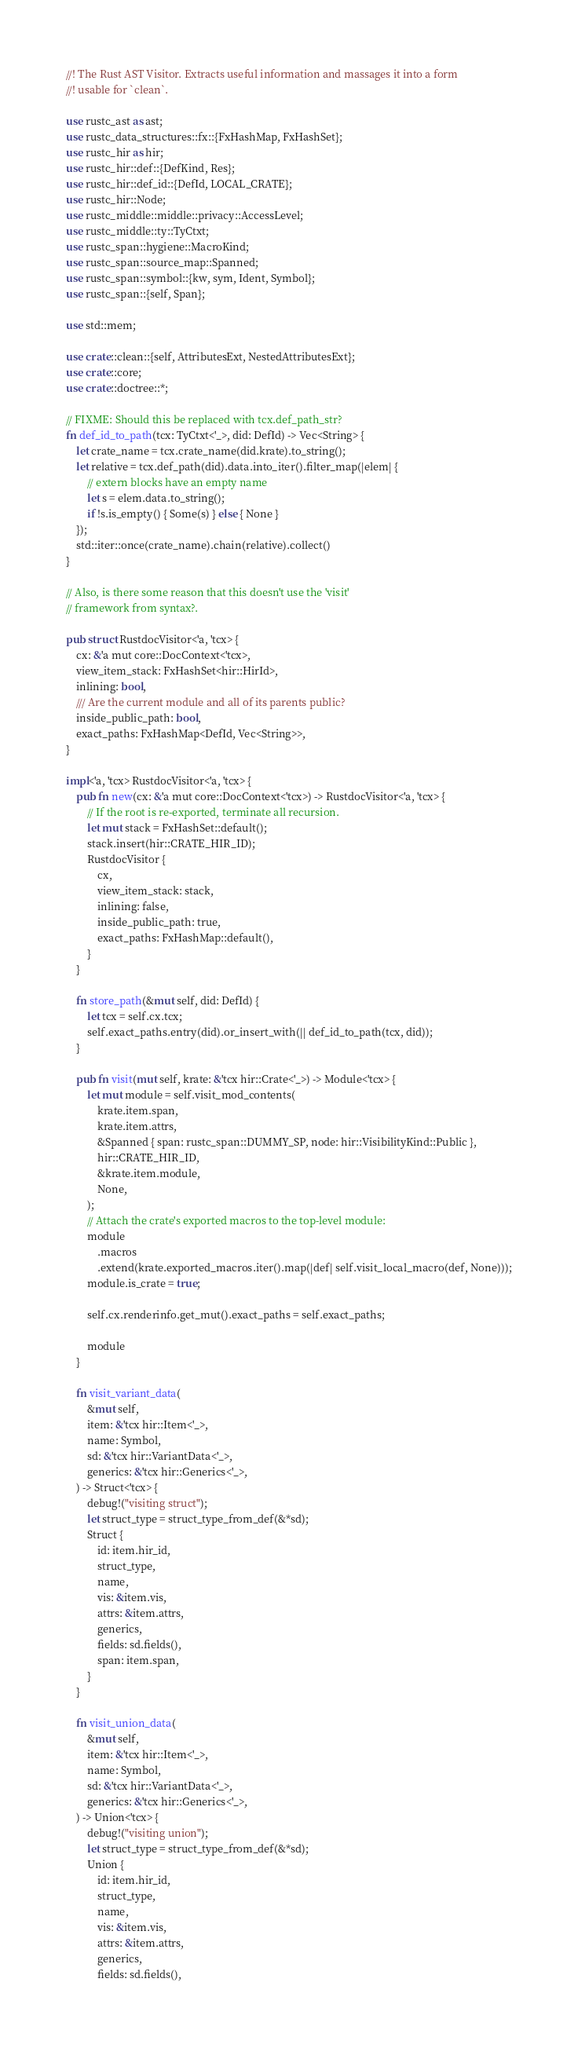Convert code to text. <code><loc_0><loc_0><loc_500><loc_500><_Rust_>//! The Rust AST Visitor. Extracts useful information and massages it into a form
//! usable for `clean`.

use rustc_ast as ast;
use rustc_data_structures::fx::{FxHashMap, FxHashSet};
use rustc_hir as hir;
use rustc_hir::def::{DefKind, Res};
use rustc_hir::def_id::{DefId, LOCAL_CRATE};
use rustc_hir::Node;
use rustc_middle::middle::privacy::AccessLevel;
use rustc_middle::ty::TyCtxt;
use rustc_span::hygiene::MacroKind;
use rustc_span::source_map::Spanned;
use rustc_span::symbol::{kw, sym, Ident, Symbol};
use rustc_span::{self, Span};

use std::mem;

use crate::clean::{self, AttributesExt, NestedAttributesExt};
use crate::core;
use crate::doctree::*;

// FIXME: Should this be replaced with tcx.def_path_str?
fn def_id_to_path(tcx: TyCtxt<'_>, did: DefId) -> Vec<String> {
    let crate_name = tcx.crate_name(did.krate).to_string();
    let relative = tcx.def_path(did).data.into_iter().filter_map(|elem| {
        // extern blocks have an empty name
        let s = elem.data.to_string();
        if !s.is_empty() { Some(s) } else { None }
    });
    std::iter::once(crate_name).chain(relative).collect()
}

// Also, is there some reason that this doesn't use the 'visit'
// framework from syntax?.

pub struct RustdocVisitor<'a, 'tcx> {
    cx: &'a mut core::DocContext<'tcx>,
    view_item_stack: FxHashSet<hir::HirId>,
    inlining: bool,
    /// Are the current module and all of its parents public?
    inside_public_path: bool,
    exact_paths: FxHashMap<DefId, Vec<String>>,
}

impl<'a, 'tcx> RustdocVisitor<'a, 'tcx> {
    pub fn new(cx: &'a mut core::DocContext<'tcx>) -> RustdocVisitor<'a, 'tcx> {
        // If the root is re-exported, terminate all recursion.
        let mut stack = FxHashSet::default();
        stack.insert(hir::CRATE_HIR_ID);
        RustdocVisitor {
            cx,
            view_item_stack: stack,
            inlining: false,
            inside_public_path: true,
            exact_paths: FxHashMap::default(),
        }
    }

    fn store_path(&mut self, did: DefId) {
        let tcx = self.cx.tcx;
        self.exact_paths.entry(did).or_insert_with(|| def_id_to_path(tcx, did));
    }

    pub fn visit(mut self, krate: &'tcx hir::Crate<'_>) -> Module<'tcx> {
        let mut module = self.visit_mod_contents(
            krate.item.span,
            krate.item.attrs,
            &Spanned { span: rustc_span::DUMMY_SP, node: hir::VisibilityKind::Public },
            hir::CRATE_HIR_ID,
            &krate.item.module,
            None,
        );
        // Attach the crate's exported macros to the top-level module:
        module
            .macros
            .extend(krate.exported_macros.iter().map(|def| self.visit_local_macro(def, None)));
        module.is_crate = true;

        self.cx.renderinfo.get_mut().exact_paths = self.exact_paths;

        module
    }

    fn visit_variant_data(
        &mut self,
        item: &'tcx hir::Item<'_>,
        name: Symbol,
        sd: &'tcx hir::VariantData<'_>,
        generics: &'tcx hir::Generics<'_>,
    ) -> Struct<'tcx> {
        debug!("visiting struct");
        let struct_type = struct_type_from_def(&*sd);
        Struct {
            id: item.hir_id,
            struct_type,
            name,
            vis: &item.vis,
            attrs: &item.attrs,
            generics,
            fields: sd.fields(),
            span: item.span,
        }
    }

    fn visit_union_data(
        &mut self,
        item: &'tcx hir::Item<'_>,
        name: Symbol,
        sd: &'tcx hir::VariantData<'_>,
        generics: &'tcx hir::Generics<'_>,
    ) -> Union<'tcx> {
        debug!("visiting union");
        let struct_type = struct_type_from_def(&*sd);
        Union {
            id: item.hir_id,
            struct_type,
            name,
            vis: &item.vis,
            attrs: &item.attrs,
            generics,
            fields: sd.fields(),</code> 